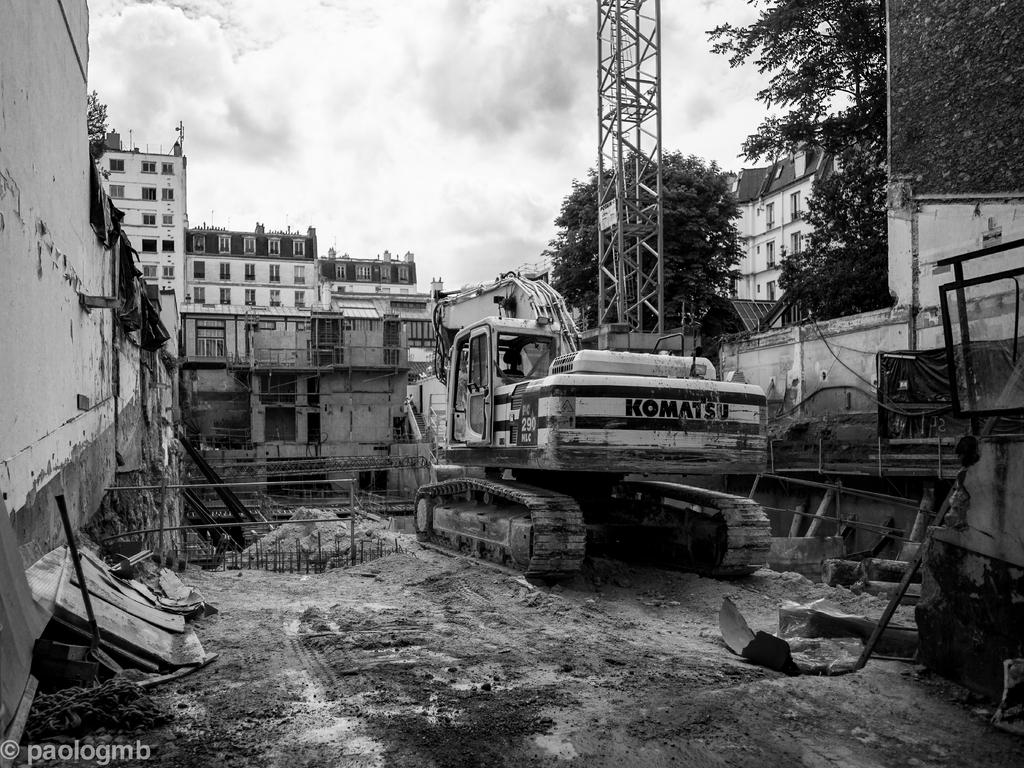What is located on the ground in the image? There is a vehicle on the ground in the image. What can be seen in the distance behind the vehicle? There are buildings and trees in the background of the image. What is visible in the sky in the image? The sky is visible in the background of the image. Is there any text present in the image? Yes, there is some text in the bottom left corner of the image. What language are the ants speaking in the image? There are no ants present in the image, so it is not possible to determine the language they might be speaking. 